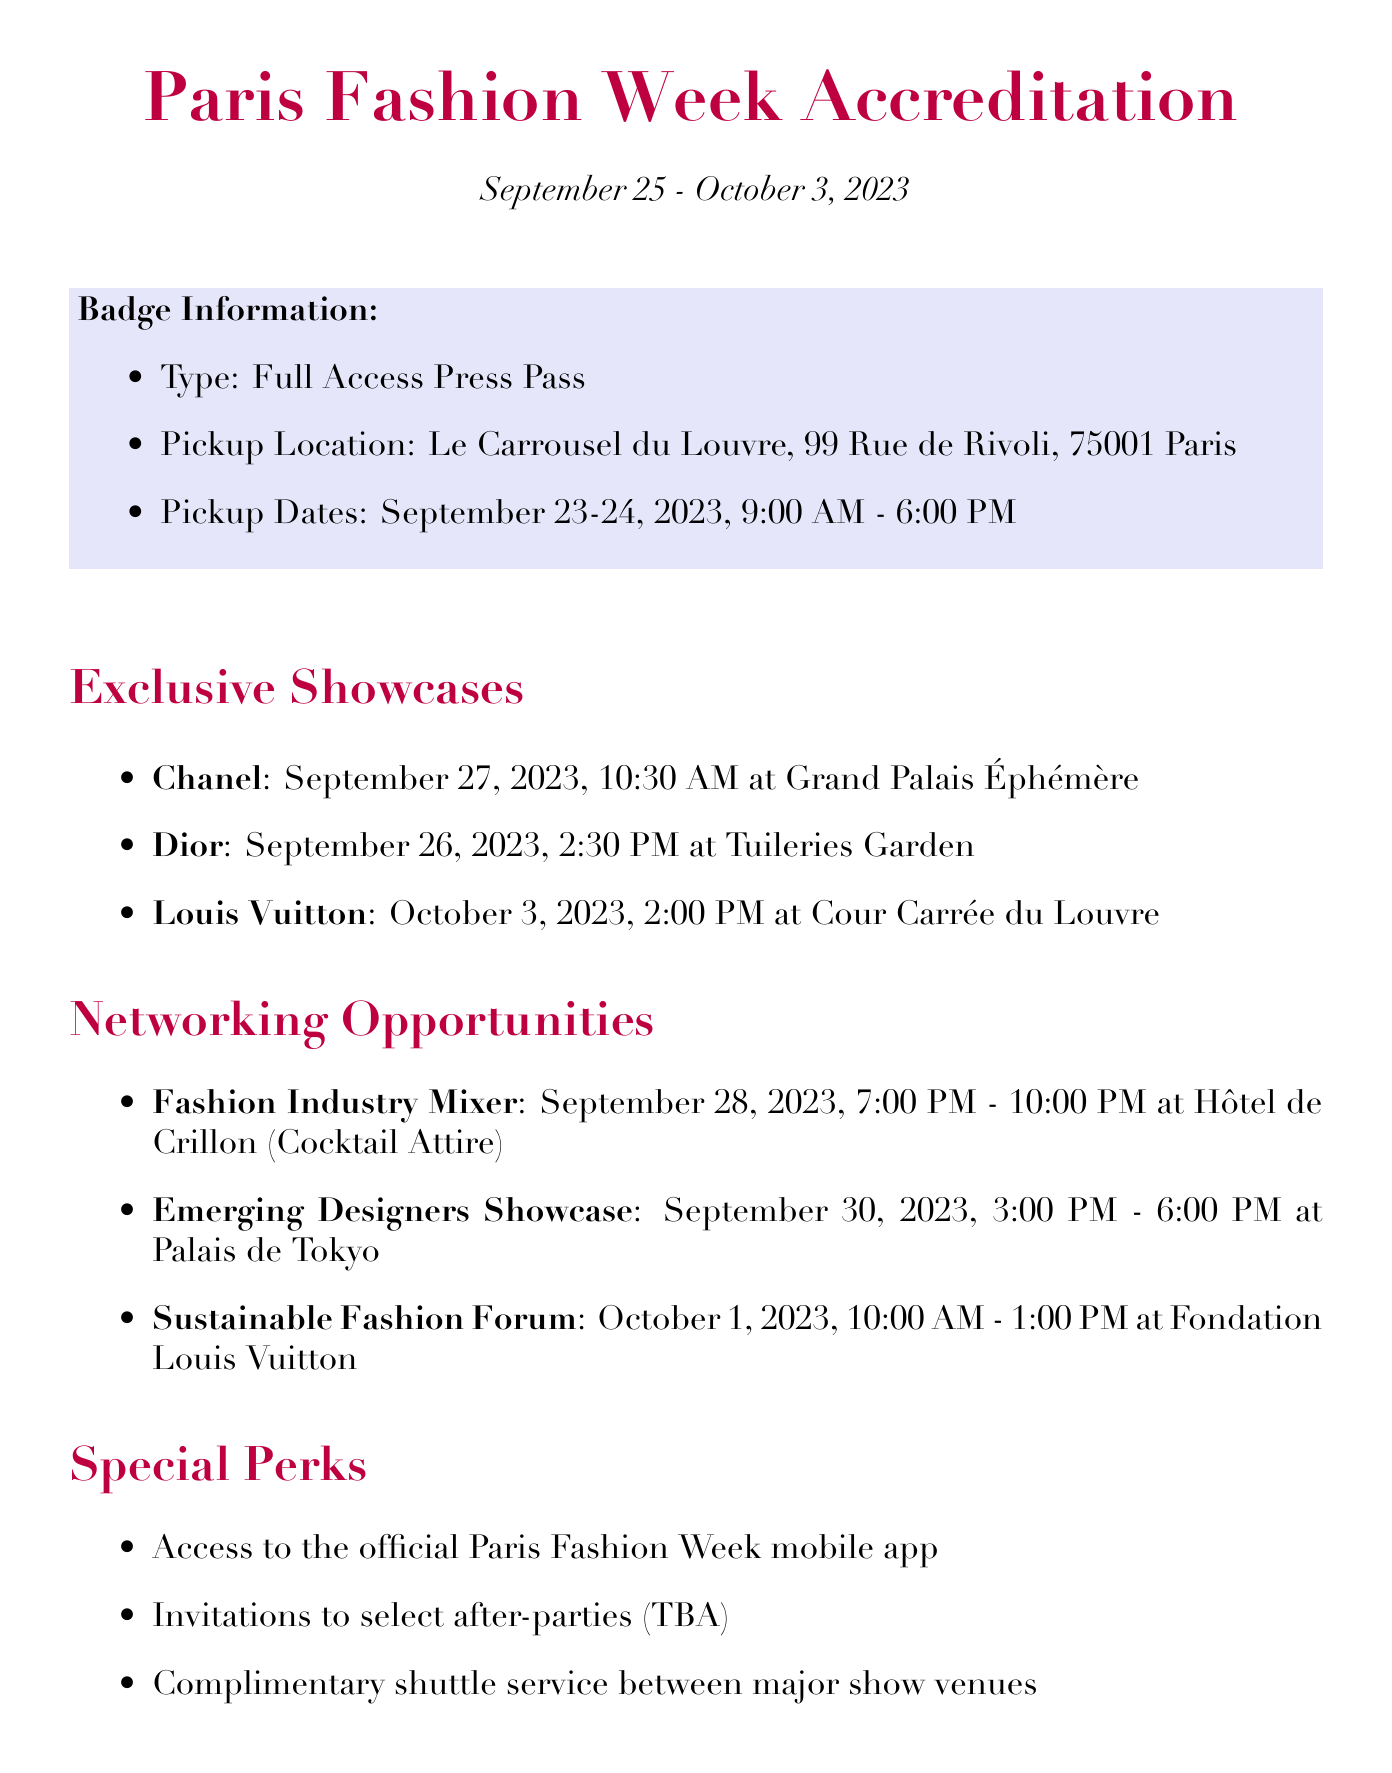What are the dates for Paris Fashion Week? The document specifies that Paris Fashion Week runs from September 25 to October 3, 2023.
Answer: September 25 - October 3, 2023 Where will the Fashion Industry Mixer take place? The document mentions that the Fashion Industry Mixer is held at Hôtel de Crillon.
Answer: Hôtel de Crillon What type of pass is provided for accreditation? The document states that the type of pass is a Full Access Press Pass.
Answer: Full Access Press Pass When is the Chanel showcase scheduled? The Chanel showcase is scheduled for September 27, 2023, at 10:30 AM.
Answer: September 27, 2023, 10:30 AM What is required to collect samples as a stylist? The document lists Stylist ID, Accreditation Badge, and Appointment Confirmation as required documents.
Answer: Stylist ID, Accreditation Badge, and Appointment Confirmation Which venue is hosting the Sustainable Fashion Forum? The Sustainable Fashion Forum will take place at Fondation Louis Vuitton.
Answer: Fondation Louis Vuitton What will happen if one does not wear a mask at the venues? The document specifies a mask requirement as mandatory in all indoor venues.
Answer: Mandatory How many exclusive showcases are mentioned? The document lists three exclusive showcases by different designers during the event.
Answer: Three What is the dress code for the Fashion Industry Mixer? The dress code for the Fashion Industry Mixer is specified as Cocktail Attire.
Answer: Cocktail Attire 